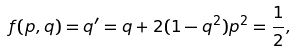Convert formula to latex. <formula><loc_0><loc_0><loc_500><loc_500>f ( p , q ) = q ^ { \prime } = q + 2 ( 1 - q ^ { 2 } ) p ^ { 2 } = \frac { 1 } { 2 } ,</formula> 